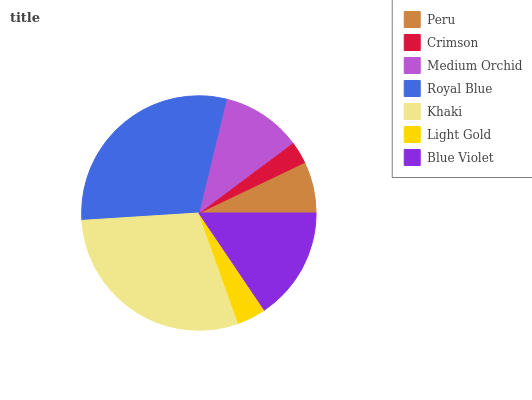Is Crimson the minimum?
Answer yes or no. Yes. Is Royal Blue the maximum?
Answer yes or no. Yes. Is Medium Orchid the minimum?
Answer yes or no. No. Is Medium Orchid the maximum?
Answer yes or no. No. Is Medium Orchid greater than Crimson?
Answer yes or no. Yes. Is Crimson less than Medium Orchid?
Answer yes or no. Yes. Is Crimson greater than Medium Orchid?
Answer yes or no. No. Is Medium Orchid less than Crimson?
Answer yes or no. No. Is Medium Orchid the high median?
Answer yes or no. Yes. Is Medium Orchid the low median?
Answer yes or no. Yes. Is Royal Blue the high median?
Answer yes or no. No. Is Royal Blue the low median?
Answer yes or no. No. 